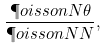<formula> <loc_0><loc_0><loc_500><loc_500>\frac { \P o i s s o n { N } { \theta } } { \P o i s s o n { N } { N } } ,</formula> 